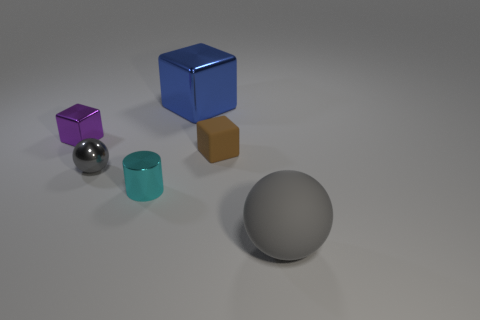There is a tiny metal object that is the same color as the matte ball; what is its shape?
Your answer should be compact. Sphere. How many big objects are either gray rubber cylinders or purple metallic blocks?
Make the answer very short. 0. Is there anything else that is the same color as the large ball?
Ensure brevity in your answer.  Yes. What size is the block that is on the right side of the tiny gray object and in front of the big blue block?
Ensure brevity in your answer.  Small. There is a tiny thing behind the brown thing; is its color the same as the shiny block that is to the right of the cyan shiny cylinder?
Make the answer very short. No. What number of other objects are there of the same material as the cylinder?
Your answer should be compact. 3. What shape is the object that is left of the small cylinder and in front of the purple metal object?
Make the answer very short. Sphere. There is a small cylinder; is its color the same as the large object left of the rubber sphere?
Your response must be concise. No. Do the gray ball that is to the right of the brown rubber thing and the big block have the same size?
Provide a succinct answer. Yes. There is a brown object that is the same shape as the small purple metal thing; what material is it?
Provide a short and direct response. Rubber. 